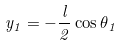<formula> <loc_0><loc_0><loc_500><loc_500>y _ { 1 } = - \frac { l } { 2 } \cos \theta _ { 1 }</formula> 